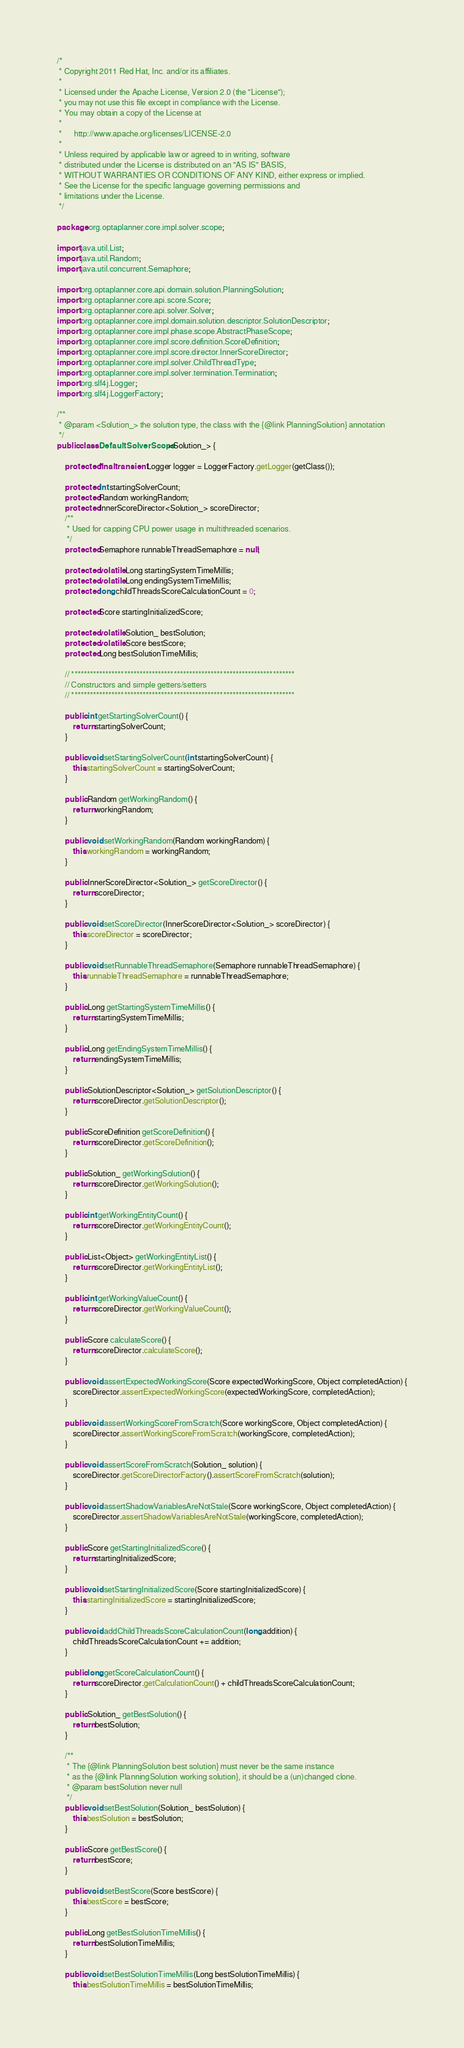Convert code to text. <code><loc_0><loc_0><loc_500><loc_500><_Java_>/*
 * Copyright 2011 Red Hat, Inc. and/or its affiliates.
 *
 * Licensed under the Apache License, Version 2.0 (the "License");
 * you may not use this file except in compliance with the License.
 * You may obtain a copy of the License at
 *
 *      http://www.apache.org/licenses/LICENSE-2.0
 *
 * Unless required by applicable law or agreed to in writing, software
 * distributed under the License is distributed on an "AS IS" BASIS,
 * WITHOUT WARRANTIES OR CONDITIONS OF ANY KIND, either express or implied.
 * See the License for the specific language governing permissions and
 * limitations under the License.
 */

package org.optaplanner.core.impl.solver.scope;

import java.util.List;
import java.util.Random;
import java.util.concurrent.Semaphore;

import org.optaplanner.core.api.domain.solution.PlanningSolution;
import org.optaplanner.core.api.score.Score;
import org.optaplanner.core.api.solver.Solver;
import org.optaplanner.core.impl.domain.solution.descriptor.SolutionDescriptor;
import org.optaplanner.core.impl.phase.scope.AbstractPhaseScope;
import org.optaplanner.core.impl.score.definition.ScoreDefinition;
import org.optaplanner.core.impl.score.director.InnerScoreDirector;
import org.optaplanner.core.impl.solver.ChildThreadType;
import org.optaplanner.core.impl.solver.termination.Termination;
import org.slf4j.Logger;
import org.slf4j.LoggerFactory;

/**
 * @param <Solution_> the solution type, the class with the {@link PlanningSolution} annotation
 */
public class DefaultSolverScope<Solution_> {

    protected final transient Logger logger = LoggerFactory.getLogger(getClass());

    protected int startingSolverCount;
    protected Random workingRandom;
    protected InnerScoreDirector<Solution_> scoreDirector;
    /**
     * Used for capping CPU power usage in multithreaded scenarios.
     */
    protected Semaphore runnableThreadSemaphore = null;

    protected volatile Long startingSystemTimeMillis;
    protected volatile Long endingSystemTimeMillis;
    protected long childThreadsScoreCalculationCount = 0;

    protected Score startingInitializedScore;

    protected volatile Solution_ bestSolution;
    protected volatile Score bestScore;
    protected Long bestSolutionTimeMillis;

    // ************************************************************************
    // Constructors and simple getters/setters
    // ************************************************************************

    public int getStartingSolverCount() {
        return startingSolverCount;
    }

    public void setStartingSolverCount(int startingSolverCount) {
        this.startingSolverCount = startingSolverCount;
    }

    public Random getWorkingRandom() {
        return workingRandom;
    }

    public void setWorkingRandom(Random workingRandom) {
        this.workingRandom = workingRandom;
    }

    public InnerScoreDirector<Solution_> getScoreDirector() {
        return scoreDirector;
    }

    public void setScoreDirector(InnerScoreDirector<Solution_> scoreDirector) {
        this.scoreDirector = scoreDirector;
    }

    public void setRunnableThreadSemaphore(Semaphore runnableThreadSemaphore) {
        this.runnableThreadSemaphore = runnableThreadSemaphore;
    }

    public Long getStartingSystemTimeMillis() {
        return startingSystemTimeMillis;
    }

    public Long getEndingSystemTimeMillis() {
        return endingSystemTimeMillis;
    }

    public SolutionDescriptor<Solution_> getSolutionDescriptor() {
        return scoreDirector.getSolutionDescriptor();
    }

    public ScoreDefinition getScoreDefinition() {
        return scoreDirector.getScoreDefinition();
    }

    public Solution_ getWorkingSolution() {
        return scoreDirector.getWorkingSolution();
    }

    public int getWorkingEntityCount() {
        return scoreDirector.getWorkingEntityCount();
    }

    public List<Object> getWorkingEntityList() {
        return scoreDirector.getWorkingEntityList();
    }

    public int getWorkingValueCount() {
        return scoreDirector.getWorkingValueCount();
    }

    public Score calculateScore() {
        return scoreDirector.calculateScore();
    }

    public void assertExpectedWorkingScore(Score expectedWorkingScore, Object completedAction) {
        scoreDirector.assertExpectedWorkingScore(expectedWorkingScore, completedAction);
    }

    public void assertWorkingScoreFromScratch(Score workingScore, Object completedAction) {
        scoreDirector.assertWorkingScoreFromScratch(workingScore, completedAction);
    }

    public void assertScoreFromScratch(Solution_ solution) {
        scoreDirector.getScoreDirectorFactory().assertScoreFromScratch(solution);
    }

    public void assertShadowVariablesAreNotStale(Score workingScore, Object completedAction) {
        scoreDirector.assertShadowVariablesAreNotStale(workingScore, completedAction);
    }

    public Score getStartingInitializedScore() {
        return startingInitializedScore;
    }

    public void setStartingInitializedScore(Score startingInitializedScore) {
        this.startingInitializedScore = startingInitializedScore;
    }

    public void addChildThreadsScoreCalculationCount(long addition) {
        childThreadsScoreCalculationCount += addition;
    }

    public long getScoreCalculationCount() {
        return scoreDirector.getCalculationCount() + childThreadsScoreCalculationCount;
    }

    public Solution_ getBestSolution() {
        return bestSolution;
    }

    /**
     * The {@link PlanningSolution best solution} must never be the same instance
     * as the {@link PlanningSolution working solution}, it should be a (un)changed clone.
     * @param bestSolution never null
     */
    public void setBestSolution(Solution_ bestSolution) {
        this.bestSolution = bestSolution;
    }

    public Score getBestScore() {
        return bestScore;
    }

    public void setBestScore(Score bestScore) {
        this.bestScore = bestScore;
    }

    public Long getBestSolutionTimeMillis() {
        return bestSolutionTimeMillis;
    }

    public void setBestSolutionTimeMillis(Long bestSolutionTimeMillis) {
        this.bestSolutionTimeMillis = bestSolutionTimeMillis;</code> 